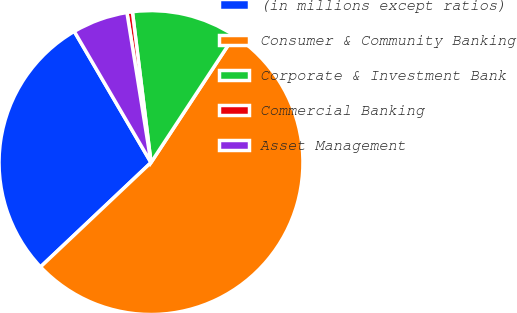<chart> <loc_0><loc_0><loc_500><loc_500><pie_chart><fcel>(in millions except ratios)<fcel>Consumer & Community Banking<fcel>Corporate & Investment Bank<fcel>Commercial Banking<fcel>Asset Management<nl><fcel>28.62%<fcel>53.69%<fcel>11.21%<fcel>0.58%<fcel>5.89%<nl></chart> 